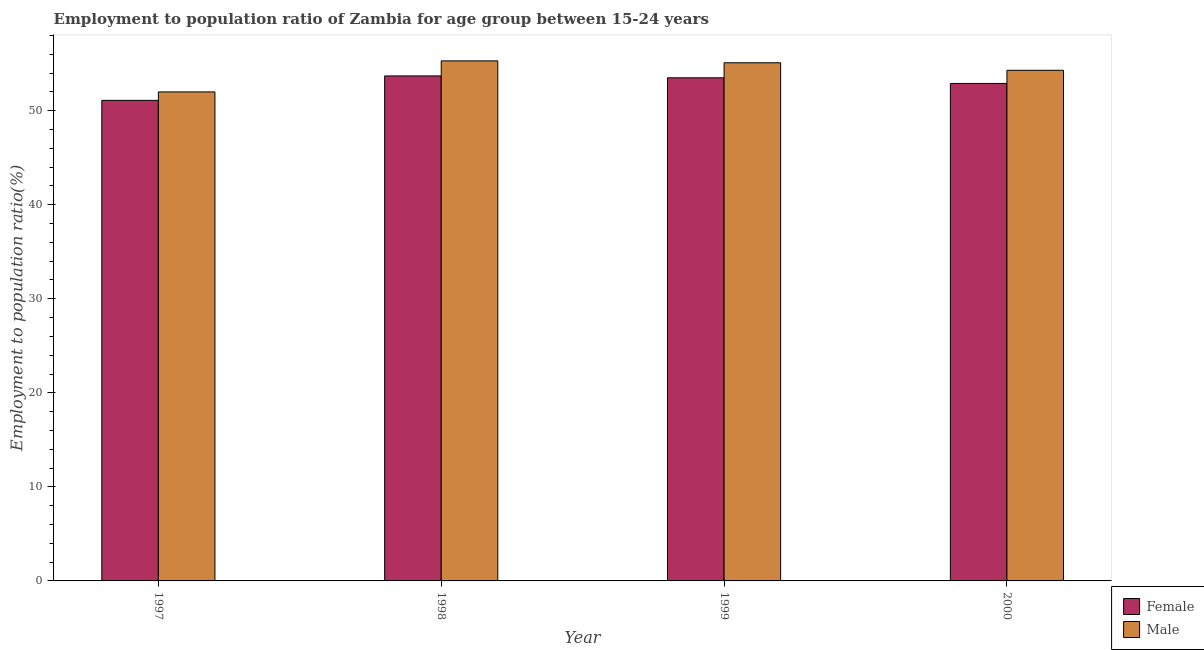How many groups of bars are there?
Provide a succinct answer. 4. Are the number of bars per tick equal to the number of legend labels?
Offer a terse response. Yes. What is the employment to population ratio(male) in 1998?
Your answer should be very brief. 55.3. Across all years, what is the maximum employment to population ratio(male)?
Provide a short and direct response. 55.3. Across all years, what is the minimum employment to population ratio(female)?
Your response must be concise. 51.1. In which year was the employment to population ratio(female) minimum?
Provide a short and direct response. 1997. What is the total employment to population ratio(female) in the graph?
Offer a terse response. 211.2. What is the difference between the employment to population ratio(male) in 1999 and that in 2000?
Provide a succinct answer. 0.8. What is the difference between the employment to population ratio(male) in 1998 and the employment to population ratio(female) in 2000?
Give a very brief answer. 1. What is the average employment to population ratio(male) per year?
Give a very brief answer. 54.17. In the year 1998, what is the difference between the employment to population ratio(female) and employment to population ratio(male)?
Provide a succinct answer. 0. What is the ratio of the employment to population ratio(male) in 1997 to that in 2000?
Provide a succinct answer. 0.96. Is the difference between the employment to population ratio(female) in 1997 and 2000 greater than the difference between the employment to population ratio(male) in 1997 and 2000?
Keep it short and to the point. No. What is the difference between the highest and the second highest employment to population ratio(female)?
Give a very brief answer. 0.2. What is the difference between the highest and the lowest employment to population ratio(male)?
Ensure brevity in your answer.  3.3. In how many years, is the employment to population ratio(female) greater than the average employment to population ratio(female) taken over all years?
Make the answer very short. 3. Is the sum of the employment to population ratio(male) in 1997 and 2000 greater than the maximum employment to population ratio(female) across all years?
Offer a very short reply. Yes. What does the 1st bar from the right in 1997 represents?
Offer a very short reply. Male. How many years are there in the graph?
Provide a succinct answer. 4. Does the graph contain any zero values?
Provide a succinct answer. No. Does the graph contain grids?
Keep it short and to the point. No. Where does the legend appear in the graph?
Your response must be concise. Bottom right. How many legend labels are there?
Keep it short and to the point. 2. What is the title of the graph?
Your response must be concise. Employment to population ratio of Zambia for age group between 15-24 years. What is the label or title of the X-axis?
Offer a very short reply. Year. What is the Employment to population ratio(%) in Female in 1997?
Give a very brief answer. 51.1. What is the Employment to population ratio(%) in Female in 1998?
Give a very brief answer. 53.7. What is the Employment to population ratio(%) in Male in 1998?
Offer a terse response. 55.3. What is the Employment to population ratio(%) in Female in 1999?
Provide a succinct answer. 53.5. What is the Employment to population ratio(%) of Male in 1999?
Your answer should be very brief. 55.1. What is the Employment to population ratio(%) of Female in 2000?
Provide a short and direct response. 52.9. What is the Employment to population ratio(%) of Male in 2000?
Make the answer very short. 54.3. Across all years, what is the maximum Employment to population ratio(%) of Female?
Make the answer very short. 53.7. Across all years, what is the maximum Employment to population ratio(%) of Male?
Give a very brief answer. 55.3. Across all years, what is the minimum Employment to population ratio(%) in Female?
Make the answer very short. 51.1. What is the total Employment to population ratio(%) of Female in the graph?
Provide a succinct answer. 211.2. What is the total Employment to population ratio(%) of Male in the graph?
Keep it short and to the point. 216.7. What is the difference between the Employment to population ratio(%) in Female in 1997 and that in 1999?
Ensure brevity in your answer.  -2.4. What is the difference between the Employment to population ratio(%) in Male in 1997 and that in 1999?
Provide a short and direct response. -3.1. What is the difference between the Employment to population ratio(%) of Female in 1997 and that in 2000?
Give a very brief answer. -1.8. What is the difference between the Employment to population ratio(%) in Male in 1997 and that in 2000?
Your answer should be compact. -2.3. What is the difference between the Employment to population ratio(%) in Female in 1998 and that in 1999?
Provide a succinct answer. 0.2. What is the difference between the Employment to population ratio(%) in Male in 1998 and that in 1999?
Your answer should be compact. 0.2. What is the difference between the Employment to population ratio(%) of Female in 1998 and that in 2000?
Your answer should be compact. 0.8. What is the difference between the Employment to population ratio(%) of Male in 1998 and that in 2000?
Provide a short and direct response. 1. What is the difference between the Employment to population ratio(%) of Female in 1999 and that in 2000?
Your answer should be compact. 0.6. What is the difference between the Employment to population ratio(%) of Female in 1997 and the Employment to population ratio(%) of Male in 1999?
Offer a very short reply. -4. What is the difference between the Employment to population ratio(%) in Female in 1998 and the Employment to population ratio(%) in Male in 1999?
Your answer should be very brief. -1.4. What is the difference between the Employment to population ratio(%) in Female in 1998 and the Employment to population ratio(%) in Male in 2000?
Your response must be concise. -0.6. What is the average Employment to population ratio(%) of Female per year?
Offer a terse response. 52.8. What is the average Employment to population ratio(%) of Male per year?
Provide a succinct answer. 54.17. In the year 1997, what is the difference between the Employment to population ratio(%) in Female and Employment to population ratio(%) in Male?
Keep it short and to the point. -0.9. In the year 1998, what is the difference between the Employment to population ratio(%) in Female and Employment to population ratio(%) in Male?
Your answer should be compact. -1.6. In the year 1999, what is the difference between the Employment to population ratio(%) of Female and Employment to population ratio(%) of Male?
Offer a terse response. -1.6. In the year 2000, what is the difference between the Employment to population ratio(%) in Female and Employment to population ratio(%) in Male?
Your answer should be very brief. -1.4. What is the ratio of the Employment to population ratio(%) of Female in 1997 to that in 1998?
Your answer should be compact. 0.95. What is the ratio of the Employment to population ratio(%) of Male in 1997 to that in 1998?
Ensure brevity in your answer.  0.94. What is the ratio of the Employment to population ratio(%) in Female in 1997 to that in 1999?
Make the answer very short. 0.96. What is the ratio of the Employment to population ratio(%) of Male in 1997 to that in 1999?
Provide a succinct answer. 0.94. What is the ratio of the Employment to population ratio(%) in Female in 1997 to that in 2000?
Your answer should be compact. 0.97. What is the ratio of the Employment to population ratio(%) of Male in 1997 to that in 2000?
Give a very brief answer. 0.96. What is the ratio of the Employment to population ratio(%) in Female in 1998 to that in 1999?
Provide a succinct answer. 1. What is the ratio of the Employment to population ratio(%) of Female in 1998 to that in 2000?
Make the answer very short. 1.02. What is the ratio of the Employment to population ratio(%) in Male in 1998 to that in 2000?
Offer a terse response. 1.02. What is the ratio of the Employment to population ratio(%) in Female in 1999 to that in 2000?
Provide a succinct answer. 1.01. What is the ratio of the Employment to population ratio(%) of Male in 1999 to that in 2000?
Your response must be concise. 1.01. What is the difference between the highest and the lowest Employment to population ratio(%) in Female?
Make the answer very short. 2.6. 